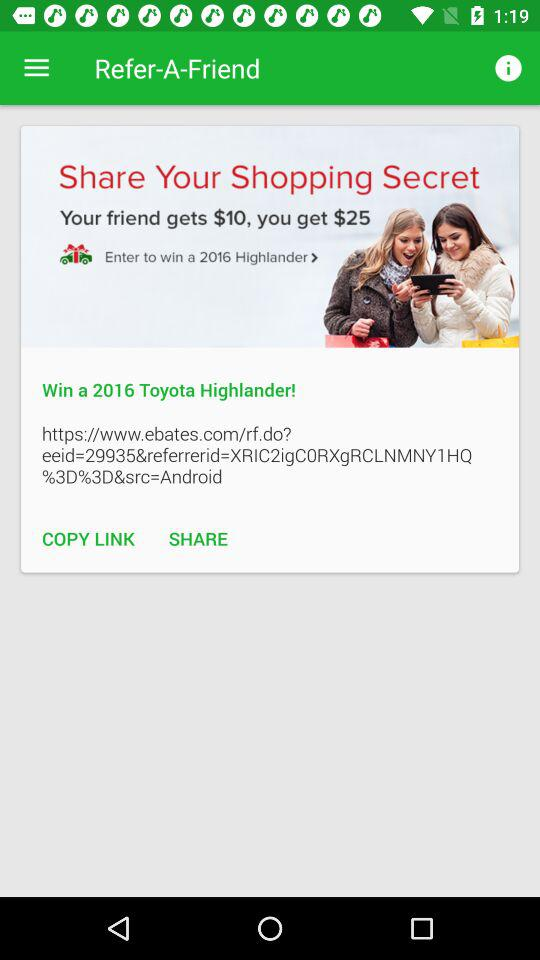How much money can I get for referring a friend? You can get $25 for referring a friend. 